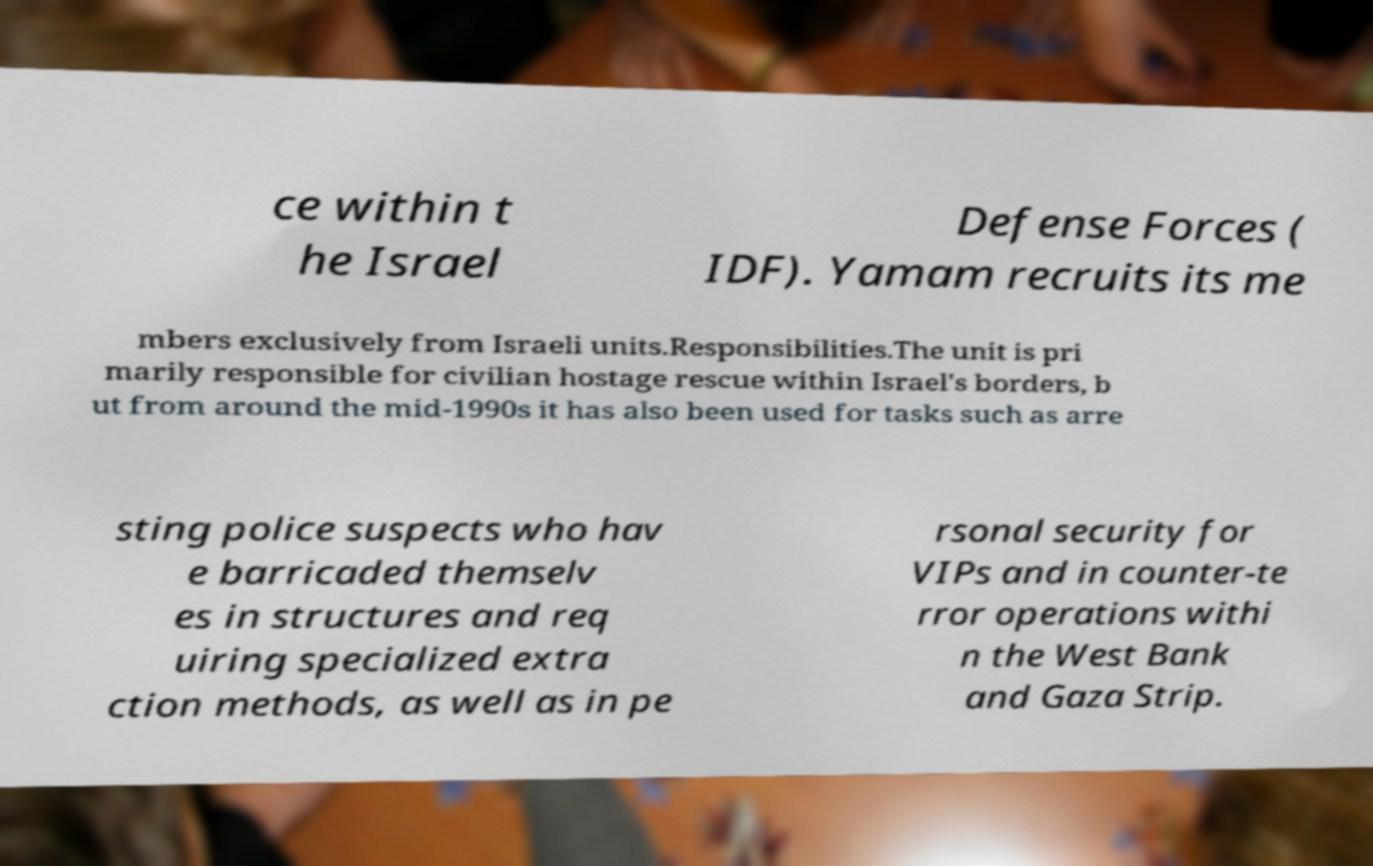Please identify and transcribe the text found in this image. ce within t he Israel Defense Forces ( IDF). Yamam recruits its me mbers exclusively from Israeli units.Responsibilities.The unit is pri marily responsible for civilian hostage rescue within Israel's borders, b ut from around the mid-1990s it has also been used for tasks such as arre sting police suspects who hav e barricaded themselv es in structures and req uiring specialized extra ction methods, as well as in pe rsonal security for VIPs and in counter-te rror operations withi n the West Bank and Gaza Strip. 